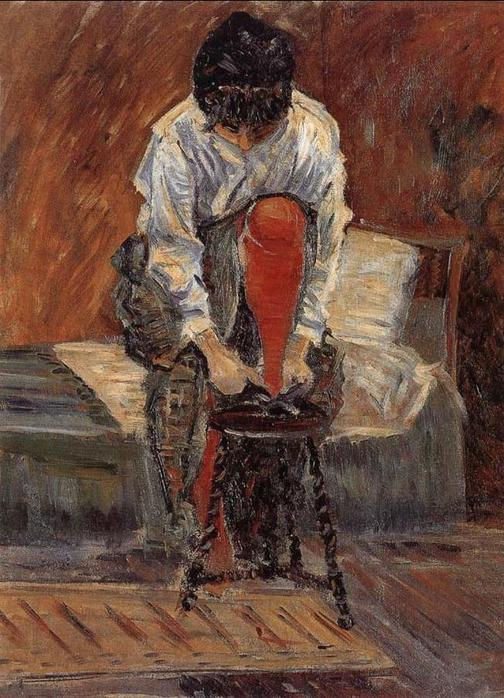Describe the following image. This is an impressionist painting capturing an intimate and quiet moment within a warm-toned room. The central figure, a woman clad in a white blouse and a vivid red skirt, sits on a wooden chair positioned near a bed. She leans forward with a deeply engrossed and contemplative air, potentially involved in tying her shoelaces. The rich brown tones of the wooden floor and chair harmoniously blend with the room's overall warm palette, contrasting with the simple white bedding and the woman's attire. The artist masterfully leverages warm colors to enhance the intimate and everyday nature of the scene, typical of the Impressionist genre. This painting elegantly portrays a moment of solitude and personal reflection, inviting viewers to ponder the woman's thoughts and emotions. 